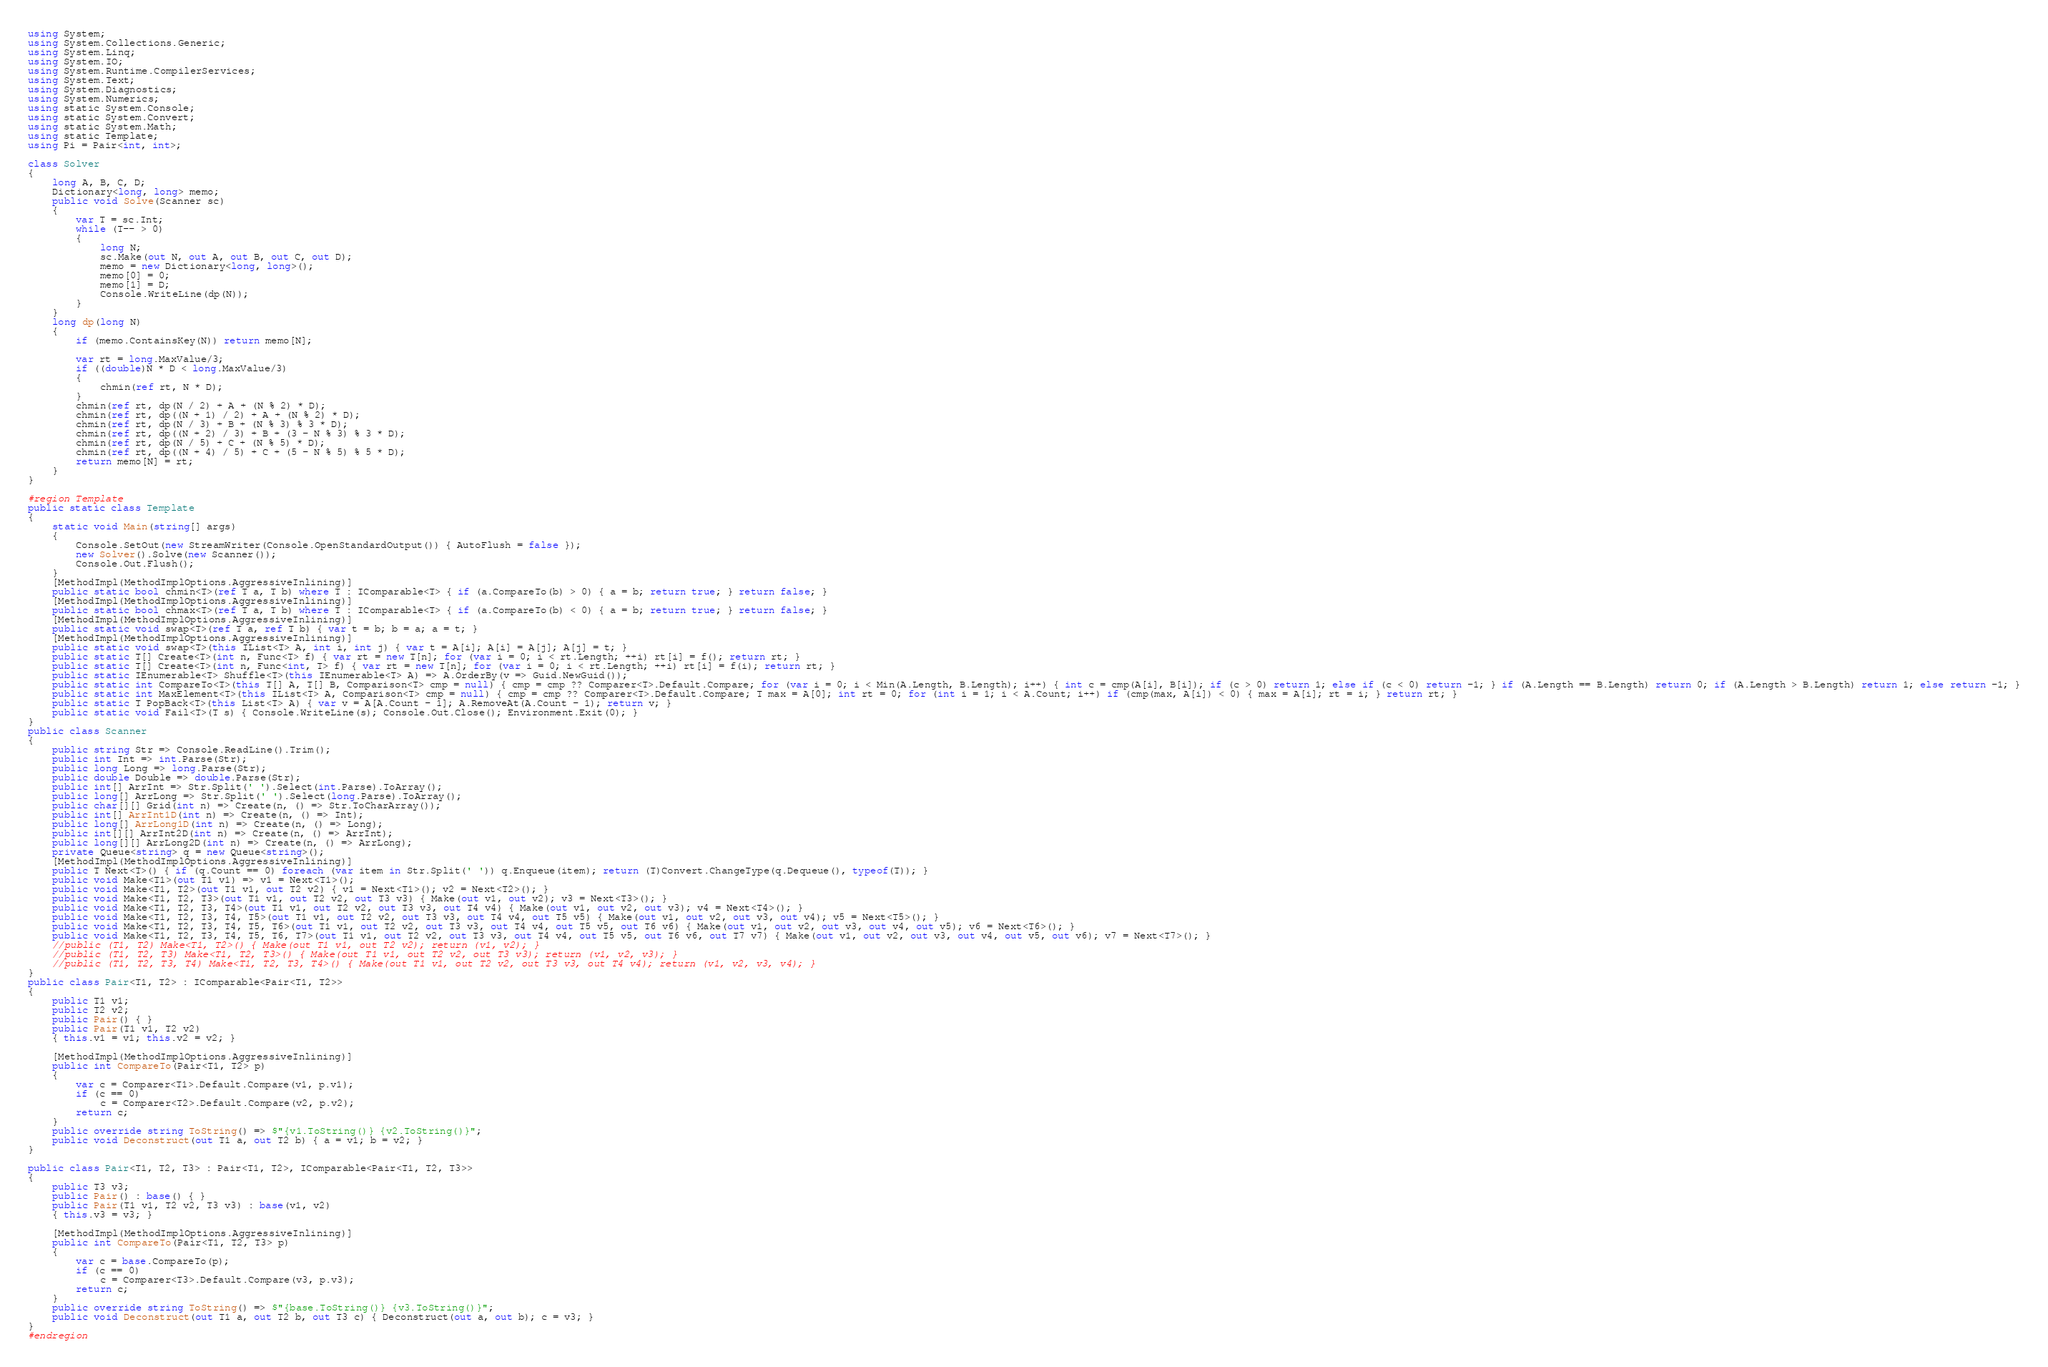Convert code to text. <code><loc_0><loc_0><loc_500><loc_500><_C#_>using System;
using System.Collections.Generic;
using System.Linq;
using System.IO;
using System.Runtime.CompilerServices;
using System.Text;
using System.Diagnostics;
using System.Numerics;
using static System.Console;
using static System.Convert;
using static System.Math;
using static Template;
using Pi = Pair<int, int>;

class Solver
{
    long A, B, C, D;
    Dictionary<long, long> memo;
    public void Solve(Scanner sc)
    {
        var T = sc.Int;
        while (T-- > 0)
        {
            long N;
            sc.Make(out N, out A, out B, out C, out D);
            memo = new Dictionary<long, long>();
            memo[0] = 0;
            memo[1] = D;
            Console.WriteLine(dp(N));
        }
    }
    long dp(long N)
    {
        if (memo.ContainsKey(N)) return memo[N];
       
        var rt = long.MaxValue/3;
        if ((double)N * D < long.MaxValue/3)
        {
            chmin(ref rt, N * D);
        }
        chmin(ref rt, dp(N / 2) + A + (N % 2) * D);
        chmin(ref rt, dp((N + 1) / 2) + A + (N % 2) * D);
        chmin(ref rt, dp(N / 3) + B + (N % 3) % 3 * D);
        chmin(ref rt, dp((N + 2) / 3) + B + (3 - N % 3) % 3 * D);
        chmin(ref rt, dp(N / 5) + C + (N % 5) * D);
        chmin(ref rt, dp((N + 4) / 5) + C + (5 - N % 5) % 5 * D);
        return memo[N] = rt;
    }
}

#region Template
public static class Template
{
    static void Main(string[] args)
    {
        Console.SetOut(new StreamWriter(Console.OpenStandardOutput()) { AutoFlush = false });
        new Solver().Solve(new Scanner());
        Console.Out.Flush();
    }
    [MethodImpl(MethodImplOptions.AggressiveInlining)]
    public static bool chmin<T>(ref T a, T b) where T : IComparable<T> { if (a.CompareTo(b) > 0) { a = b; return true; } return false; }
    [MethodImpl(MethodImplOptions.AggressiveInlining)]
    public static bool chmax<T>(ref T a, T b) where T : IComparable<T> { if (a.CompareTo(b) < 0) { a = b; return true; } return false; }
    [MethodImpl(MethodImplOptions.AggressiveInlining)]
    public static void swap<T>(ref T a, ref T b) { var t = b; b = a; a = t; }
    [MethodImpl(MethodImplOptions.AggressiveInlining)]
    public static void swap<T>(this IList<T> A, int i, int j) { var t = A[i]; A[i] = A[j]; A[j] = t; }
    public static T[] Create<T>(int n, Func<T> f) { var rt = new T[n]; for (var i = 0; i < rt.Length; ++i) rt[i] = f(); return rt; }
    public static T[] Create<T>(int n, Func<int, T> f) { var rt = new T[n]; for (var i = 0; i < rt.Length; ++i) rt[i] = f(i); return rt; }
    public static IEnumerable<T> Shuffle<T>(this IEnumerable<T> A) => A.OrderBy(v => Guid.NewGuid());
    public static int CompareTo<T>(this T[] A, T[] B, Comparison<T> cmp = null) { cmp = cmp ?? Comparer<T>.Default.Compare; for (var i = 0; i < Min(A.Length, B.Length); i++) { int c = cmp(A[i], B[i]); if (c > 0) return 1; else if (c < 0) return -1; } if (A.Length == B.Length) return 0; if (A.Length > B.Length) return 1; else return -1; }
    public static int MaxElement<T>(this IList<T> A, Comparison<T> cmp = null) { cmp = cmp ?? Comparer<T>.Default.Compare; T max = A[0]; int rt = 0; for (int i = 1; i < A.Count; i++) if (cmp(max, A[i]) < 0) { max = A[i]; rt = i; } return rt; }
    public static T PopBack<T>(this List<T> A) { var v = A[A.Count - 1]; A.RemoveAt(A.Count - 1); return v; }
    public static void Fail<T>(T s) { Console.WriteLine(s); Console.Out.Close(); Environment.Exit(0); }
}
public class Scanner
{
    public string Str => Console.ReadLine().Trim();
    public int Int => int.Parse(Str);
    public long Long => long.Parse(Str);
    public double Double => double.Parse(Str);
    public int[] ArrInt => Str.Split(' ').Select(int.Parse).ToArray();
    public long[] ArrLong => Str.Split(' ').Select(long.Parse).ToArray();
    public char[][] Grid(int n) => Create(n, () => Str.ToCharArray());
    public int[] ArrInt1D(int n) => Create(n, () => Int);
    public long[] ArrLong1D(int n) => Create(n, () => Long);
    public int[][] ArrInt2D(int n) => Create(n, () => ArrInt);
    public long[][] ArrLong2D(int n) => Create(n, () => ArrLong);
    private Queue<string> q = new Queue<string>();
    [MethodImpl(MethodImplOptions.AggressiveInlining)]
    public T Next<T>() { if (q.Count == 0) foreach (var item in Str.Split(' ')) q.Enqueue(item); return (T)Convert.ChangeType(q.Dequeue(), typeof(T)); }
    public void Make<T1>(out T1 v1) => v1 = Next<T1>();
    public void Make<T1, T2>(out T1 v1, out T2 v2) { v1 = Next<T1>(); v2 = Next<T2>(); }
    public void Make<T1, T2, T3>(out T1 v1, out T2 v2, out T3 v3) { Make(out v1, out v2); v3 = Next<T3>(); }
    public void Make<T1, T2, T3, T4>(out T1 v1, out T2 v2, out T3 v3, out T4 v4) { Make(out v1, out v2, out v3); v4 = Next<T4>(); }
    public void Make<T1, T2, T3, T4, T5>(out T1 v1, out T2 v2, out T3 v3, out T4 v4, out T5 v5) { Make(out v1, out v2, out v3, out v4); v5 = Next<T5>(); }
    public void Make<T1, T2, T3, T4, T5, T6>(out T1 v1, out T2 v2, out T3 v3, out T4 v4, out T5 v5, out T6 v6) { Make(out v1, out v2, out v3, out v4, out v5); v6 = Next<T6>(); }
    public void Make<T1, T2, T3, T4, T5, T6, T7>(out T1 v1, out T2 v2, out T3 v3, out T4 v4, out T5 v5, out T6 v6, out T7 v7) { Make(out v1, out v2, out v3, out v4, out v5, out v6); v7 = Next<T7>(); }
    //public (T1, T2) Make<T1, T2>() { Make(out T1 v1, out T2 v2); return (v1, v2); }
    //public (T1, T2, T3) Make<T1, T2, T3>() { Make(out T1 v1, out T2 v2, out T3 v3); return (v1, v2, v3); }
    //public (T1, T2, T3, T4) Make<T1, T2, T3, T4>() { Make(out T1 v1, out T2 v2, out T3 v3, out T4 v4); return (v1, v2, v3, v4); }
}
public class Pair<T1, T2> : IComparable<Pair<T1, T2>>
{
    public T1 v1;
    public T2 v2;
    public Pair() { }
    public Pair(T1 v1, T2 v2)
    { this.v1 = v1; this.v2 = v2; }

    [MethodImpl(MethodImplOptions.AggressiveInlining)]
    public int CompareTo(Pair<T1, T2> p)
    {
        var c = Comparer<T1>.Default.Compare(v1, p.v1);
        if (c == 0)
            c = Comparer<T2>.Default.Compare(v2, p.v2);
        return c;
    }
    public override string ToString() => $"{v1.ToString()} {v2.ToString()}";
    public void Deconstruct(out T1 a, out T2 b) { a = v1; b = v2; }
}

public class Pair<T1, T2, T3> : Pair<T1, T2>, IComparable<Pair<T1, T2, T3>>
{
    public T3 v3;
    public Pair() : base() { }
    public Pair(T1 v1, T2 v2, T3 v3) : base(v1, v2)
    { this.v3 = v3; }

    [MethodImpl(MethodImplOptions.AggressiveInlining)]
    public int CompareTo(Pair<T1, T2, T3> p)
    {
        var c = base.CompareTo(p);
        if (c == 0)
            c = Comparer<T3>.Default.Compare(v3, p.v3);
        return c;
    }
    public override string ToString() => $"{base.ToString()} {v3.ToString()}";
    public void Deconstruct(out T1 a, out T2 b, out T3 c) { Deconstruct(out a, out b); c = v3; }
}
#endregion
</code> 